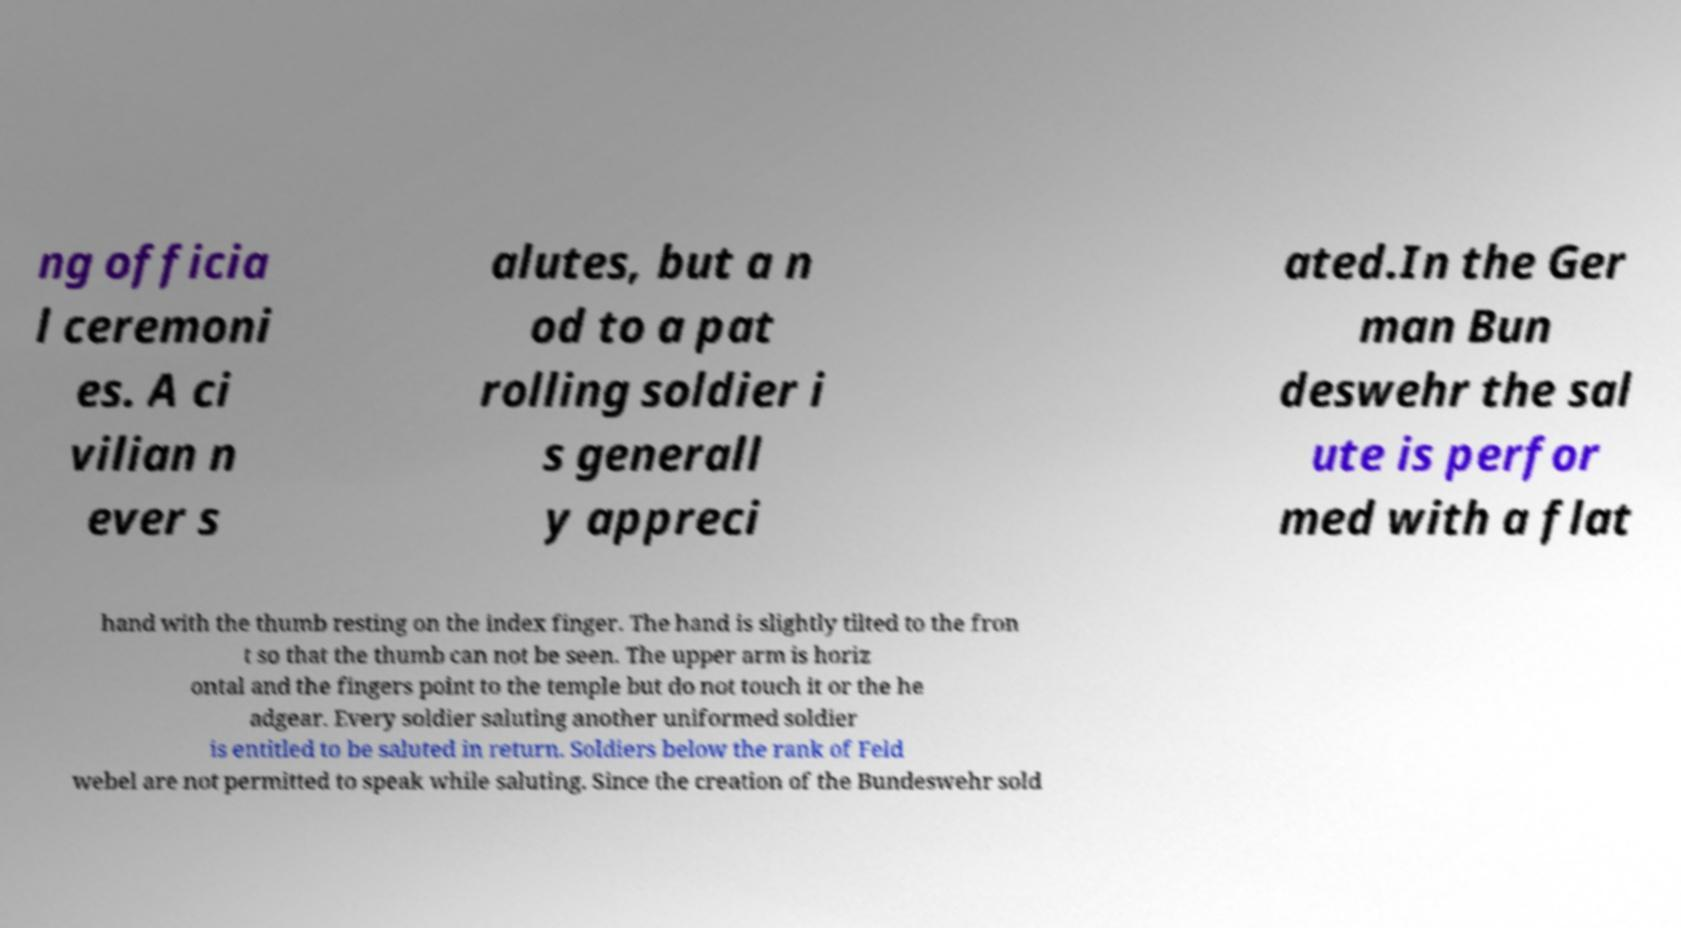There's text embedded in this image that I need extracted. Can you transcribe it verbatim? ng officia l ceremoni es. A ci vilian n ever s alutes, but a n od to a pat rolling soldier i s generall y appreci ated.In the Ger man Bun deswehr the sal ute is perfor med with a flat hand with the thumb resting on the index finger. The hand is slightly tilted to the fron t so that the thumb can not be seen. The upper arm is horiz ontal and the fingers point to the temple but do not touch it or the he adgear. Every soldier saluting another uniformed soldier is entitled to be saluted in return. Soldiers below the rank of Feld webel are not permitted to speak while saluting. Since the creation of the Bundeswehr sold 